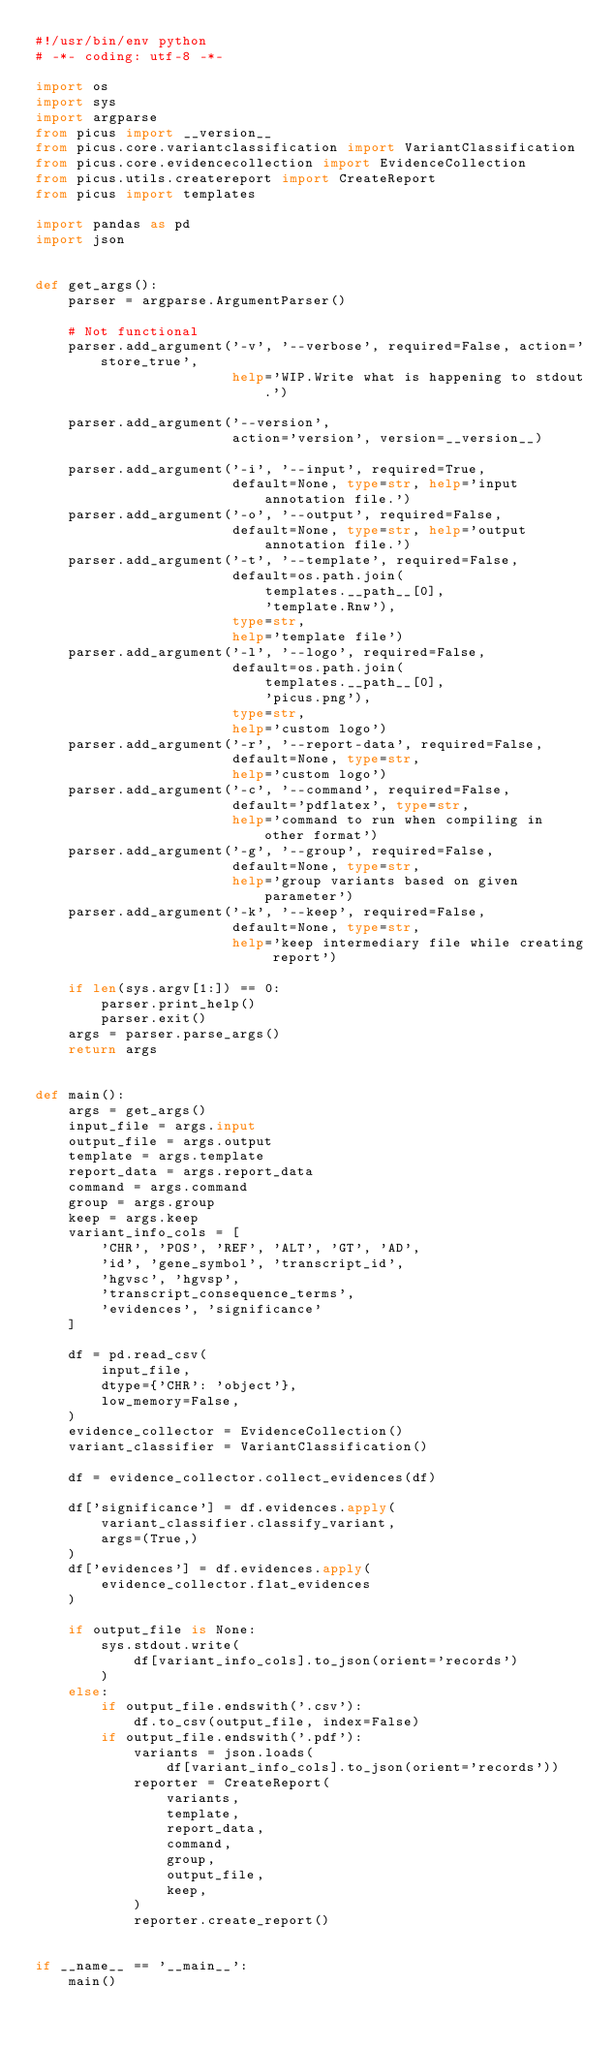<code> <loc_0><loc_0><loc_500><loc_500><_Python_>#!/usr/bin/env python
# -*- coding: utf-8 -*-

import os
import sys
import argparse
from picus import __version__
from picus.core.variantclassification import VariantClassification
from picus.core.evidencecollection import EvidenceCollection
from picus.utils.createreport import CreateReport
from picus import templates

import pandas as pd
import json


def get_args():
    parser = argparse.ArgumentParser()

    # Not functional
    parser.add_argument('-v', '--verbose', required=False, action='store_true',
                        help='WIP.Write what is happening to stdout.')

    parser.add_argument('--version',
                        action='version', version=__version__)

    parser.add_argument('-i', '--input', required=True,
                        default=None, type=str, help='input annotation file.')
    parser.add_argument('-o', '--output', required=False,
                        default=None, type=str, help='output annotation file.')
    parser.add_argument('-t', '--template', required=False,
                        default=os.path.join(
                            templates.__path__[0],
                            'template.Rnw'),
                        type=str,
                        help='template file')
    parser.add_argument('-l', '--logo', required=False,
                        default=os.path.join(
                            templates.__path__[0],
                            'picus.png'),
                        type=str,
                        help='custom logo')
    parser.add_argument('-r', '--report-data', required=False,
                        default=None, type=str,
                        help='custom logo')
    parser.add_argument('-c', '--command', required=False,
                        default='pdflatex', type=str,
                        help='command to run when compiling in other format')
    parser.add_argument('-g', '--group', required=False,
                        default=None, type=str,
                        help='group variants based on given parameter')
    parser.add_argument('-k', '--keep', required=False,
                        default=None, type=str,
                        help='keep intermediary file while creating report')

    if len(sys.argv[1:]) == 0:
        parser.print_help()
        parser.exit()
    args = parser.parse_args()
    return args


def main():
    args = get_args()
    input_file = args.input
    output_file = args.output
    template = args.template
    report_data = args.report_data
    command = args.command
    group = args.group
    keep = args.keep
    variant_info_cols = [
        'CHR', 'POS', 'REF', 'ALT', 'GT', 'AD',
        'id', 'gene_symbol', 'transcript_id',
        'hgvsc', 'hgvsp',
        'transcript_consequence_terms',
        'evidences', 'significance'
    ]

    df = pd.read_csv(
        input_file,
        dtype={'CHR': 'object'},
        low_memory=False,
    )
    evidence_collector = EvidenceCollection()
    variant_classifier = VariantClassification()

    df = evidence_collector.collect_evidences(df)

    df['significance'] = df.evidences.apply(
        variant_classifier.classify_variant,
        args=(True,)
    )
    df['evidences'] = df.evidences.apply(
        evidence_collector.flat_evidences
    )

    if output_file is None:
        sys.stdout.write(
            df[variant_info_cols].to_json(orient='records')
        )
    else:
        if output_file.endswith('.csv'):
            df.to_csv(output_file, index=False)
        if output_file.endswith('.pdf'):
            variants = json.loads(
                df[variant_info_cols].to_json(orient='records'))
            reporter = CreateReport(
                variants,
                template,
                report_data,
                command,
                group,
                output_file,
                keep,
            )
            reporter.create_report()


if __name__ == '__main__':
    main()
</code> 